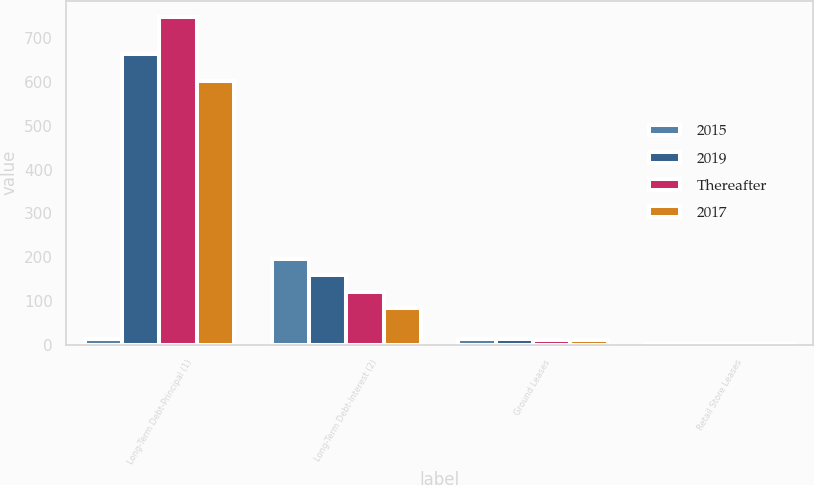Convert chart to OTSL. <chart><loc_0><loc_0><loc_500><loc_500><stacked_bar_chart><ecel><fcel>Long-Term Debt-Principal (1)<fcel>Long-Term Debt-Interest (2)<fcel>Ground Leases<fcel>Retail Store Leases<nl><fcel>2015<fcel>13.2<fcel>196.9<fcel>13.2<fcel>2.1<nl><fcel>2019<fcel>663.4<fcel>158.6<fcel>12.5<fcel>2.1<nl><fcel>Thereafter<fcel>748.5<fcel>120.4<fcel>11.6<fcel>1.6<nl><fcel>2017<fcel>602.2<fcel>83.1<fcel>10.3<fcel>1.1<nl></chart> 